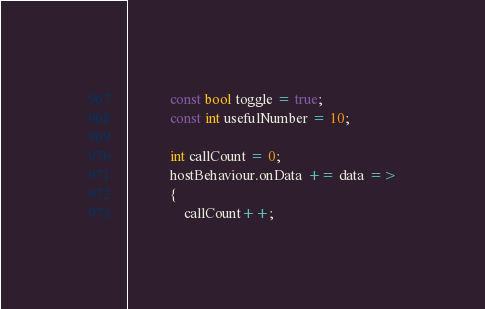Convert code to text. <code><loc_0><loc_0><loc_500><loc_500><_C#_>            const bool toggle = true;
            const int usefulNumber = 10;

            int callCount = 0;
            hostBehaviour.onData += data =>
            {
                callCount++;</code> 